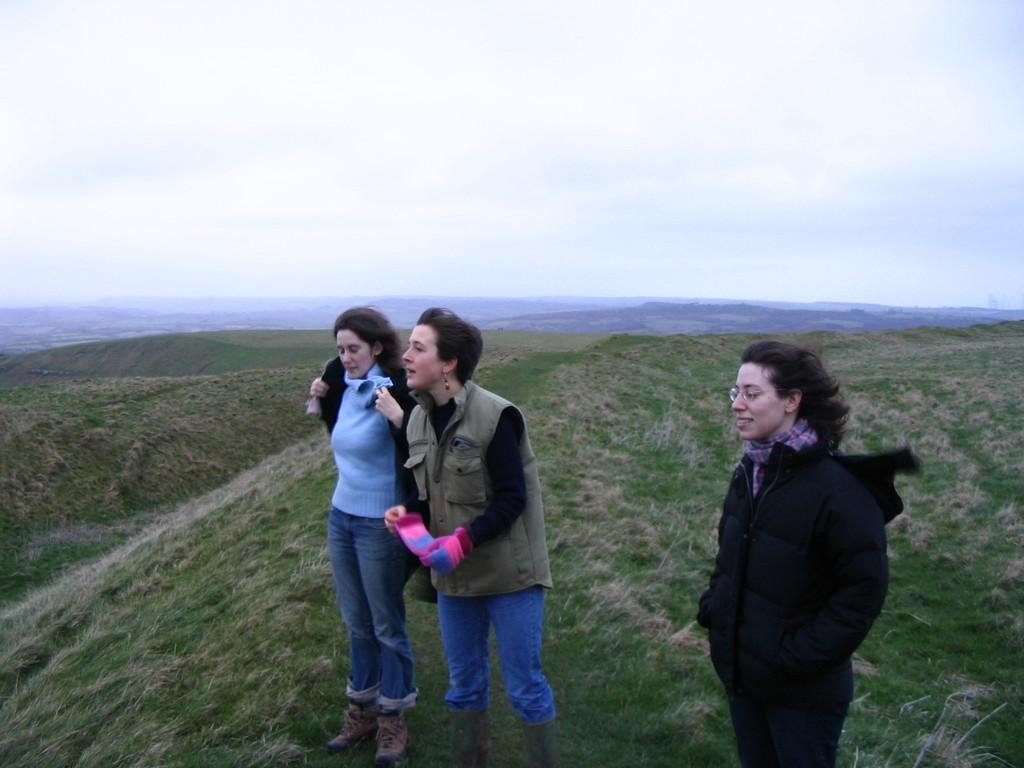How many people are in the image? There are three women in the image. Where are the women standing? The women are standing on a hill. What is visible at the top of the image? The sky is visible at the top of the image. Can you see a boy playing with a slip in the image? There is no boy or slip present in the image. What type of leaf is falling from the tree in the image? There is no tree or leaf present in the image. 